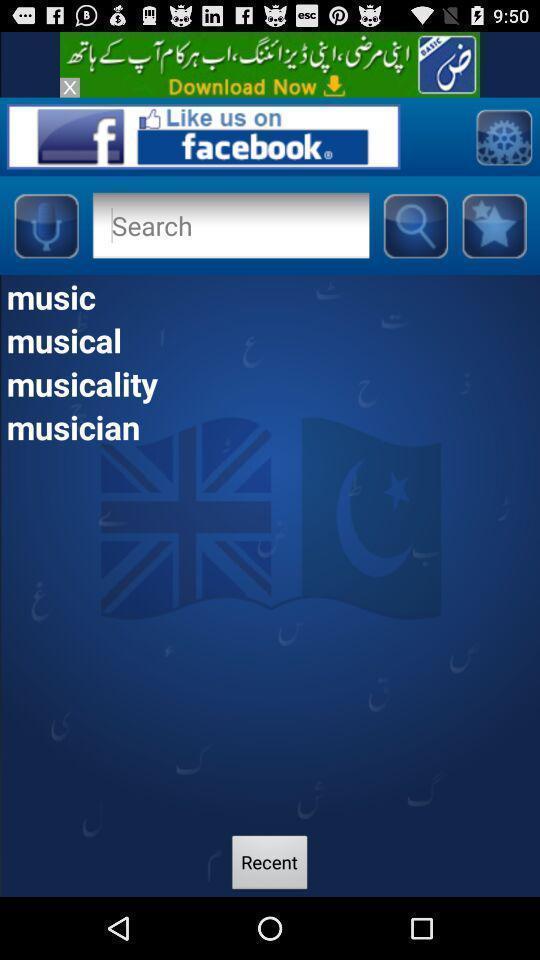What can you discern from this picture? Search page displayed. 